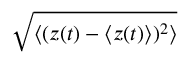Convert formula to latex. <formula><loc_0><loc_0><loc_500><loc_500>\sqrt { \langle ( z ( t ) - \langle z ( t ) \rangle ) ^ { 2 } \rangle }</formula> 